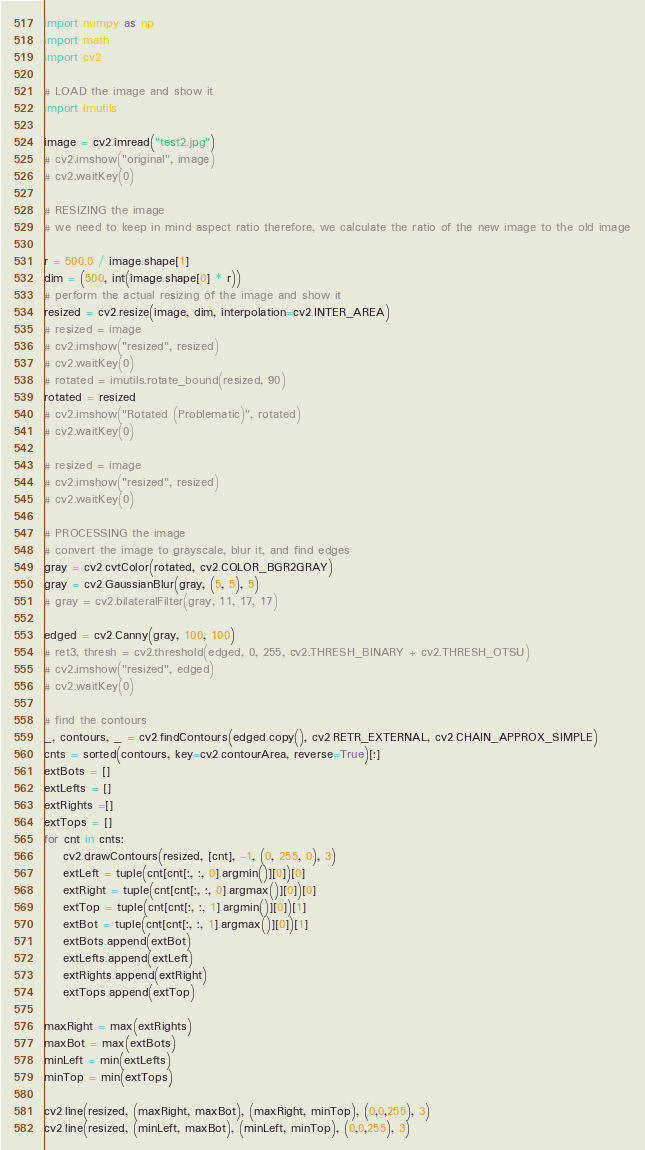Convert code to text. <code><loc_0><loc_0><loc_500><loc_500><_Python_>import numpy as np
import math
import cv2

# LOAD the image and show it
import imutils

image = cv2.imread("test2.jpg")
# cv2.imshow("original", image)
# cv2.waitKey(0)

# RESIZING the image
# we need to keep in mind aspect ratio therefore, we calculate the ratio of the new image to the old image

r = 500.0 / image.shape[1]
dim = (500, int(image.shape[0] * r))
# perform the actual resizing of the image and show it
resized = cv2.resize(image, dim, interpolation=cv2.INTER_AREA)
# resized = image
# cv2.imshow("resized", resized)
# cv2.waitKey(0)
# rotated = imutils.rotate_bound(resized, 90)
rotated = resized
# cv2.imshow("Rotated (Problematic)", rotated)
# cv2.waitKey(0)

# resized = image
# cv2.imshow("resized", resized)
# cv2.waitKey(0)

# PROCESSING the image
# convert the image to grayscale, blur it, and find edges
gray = cv2.cvtColor(rotated, cv2.COLOR_BGR2GRAY)
gray = cv2.GaussianBlur(gray, (5, 5), 5)
# gray = cv2.bilateralFilter(gray, 11, 17, 17)

edged = cv2.Canny(gray, 100, 100)
# ret3, thresh = cv2.threshold(edged, 0, 255, cv2.THRESH_BINARY + cv2.THRESH_OTSU)
# cv2.imshow("resized", edged)
# cv2.waitKey(0)

# find the contours
_, contours, _ = cv2.findContours(edged.copy(), cv2.RETR_EXTERNAL, cv2.CHAIN_APPROX_SIMPLE)
cnts = sorted(contours, key=cv2.contourArea, reverse=True)[:]
extBots = []
extLefts = []
extRights =[]
extTops = []
for cnt in cnts:
    cv2.drawContours(resized, [cnt], -1, (0, 255, 0), 3)
    extLeft = tuple(cnt[cnt[:, :, 0].argmin()][0])[0]
    extRight = tuple(cnt[cnt[:, :, 0].argmax()][0])[0]
    extTop = tuple(cnt[cnt[:, :, 1].argmin()][0])[1]
    extBot = tuple(cnt[cnt[:, :, 1].argmax()][0])[1]
    extBots.append(extBot)
    extLefts.append(extLeft)
    extRights.append(extRight)
    extTops.append(extTop)

maxRight = max(extRights)
maxBot = max(extBots)
minLeft = min(extLefts)
minTop = min(extTops)

cv2.line(resized, (maxRight, maxBot), (maxRight, minTop), (0,0,255), 3)
cv2.line(resized, (minLeft, maxBot), (minLeft, minTop), (0,0,255), 3)</code> 